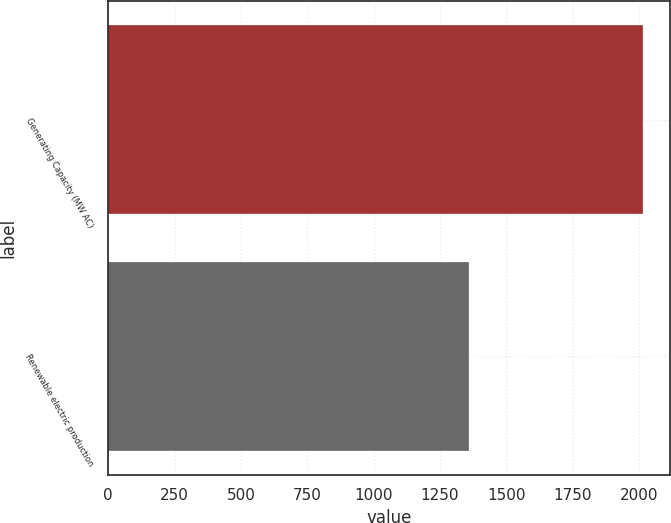<chart> <loc_0><loc_0><loc_500><loc_500><bar_chart><fcel>Generating Capacity (MW AC)<fcel>Renewable electric production<nl><fcel>2017<fcel>1358<nl></chart> 